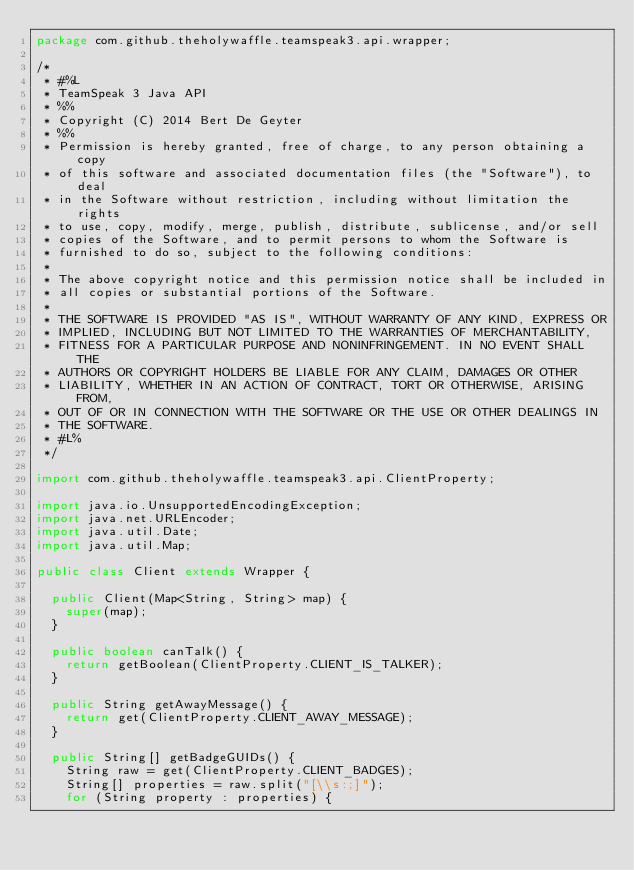<code> <loc_0><loc_0><loc_500><loc_500><_Java_>package com.github.theholywaffle.teamspeak3.api.wrapper;

/*
 * #%L
 * TeamSpeak 3 Java API
 * %%
 * Copyright (C) 2014 Bert De Geyter
 * %%
 * Permission is hereby granted, free of charge, to any person obtaining a copy
 * of this software and associated documentation files (the "Software"), to deal
 * in the Software without restriction, including without limitation the rights
 * to use, copy, modify, merge, publish, distribute, sublicense, and/or sell
 * copies of the Software, and to permit persons to whom the Software is
 * furnished to do so, subject to the following conditions:
 * 
 * The above copyright notice and this permission notice shall be included in
 * all copies or substantial portions of the Software.
 * 
 * THE SOFTWARE IS PROVIDED "AS IS", WITHOUT WARRANTY OF ANY KIND, EXPRESS OR
 * IMPLIED, INCLUDING BUT NOT LIMITED TO THE WARRANTIES OF MERCHANTABILITY,
 * FITNESS FOR A PARTICULAR PURPOSE AND NONINFRINGEMENT. IN NO EVENT SHALL THE
 * AUTHORS OR COPYRIGHT HOLDERS BE LIABLE FOR ANY CLAIM, DAMAGES OR OTHER
 * LIABILITY, WHETHER IN AN ACTION OF CONTRACT, TORT OR OTHERWISE, ARISING FROM,
 * OUT OF OR IN CONNECTION WITH THE SOFTWARE OR THE USE OR OTHER DEALINGS IN
 * THE SOFTWARE.
 * #L%
 */

import com.github.theholywaffle.teamspeak3.api.ClientProperty;

import java.io.UnsupportedEncodingException;
import java.net.URLEncoder;
import java.util.Date;
import java.util.Map;

public class Client extends Wrapper {

	public Client(Map<String, String> map) {
		super(map);
	}

	public boolean canTalk() {
		return getBoolean(ClientProperty.CLIENT_IS_TALKER);
	}

	public String getAwayMessage() {
		return get(ClientProperty.CLIENT_AWAY_MESSAGE);
	}

	public String[] getBadgeGUIDs() {
		String raw = get(ClientProperty.CLIENT_BADGES);
		String[] properties = raw.split("[\\s:;]");
		for (String property : properties) {</code> 